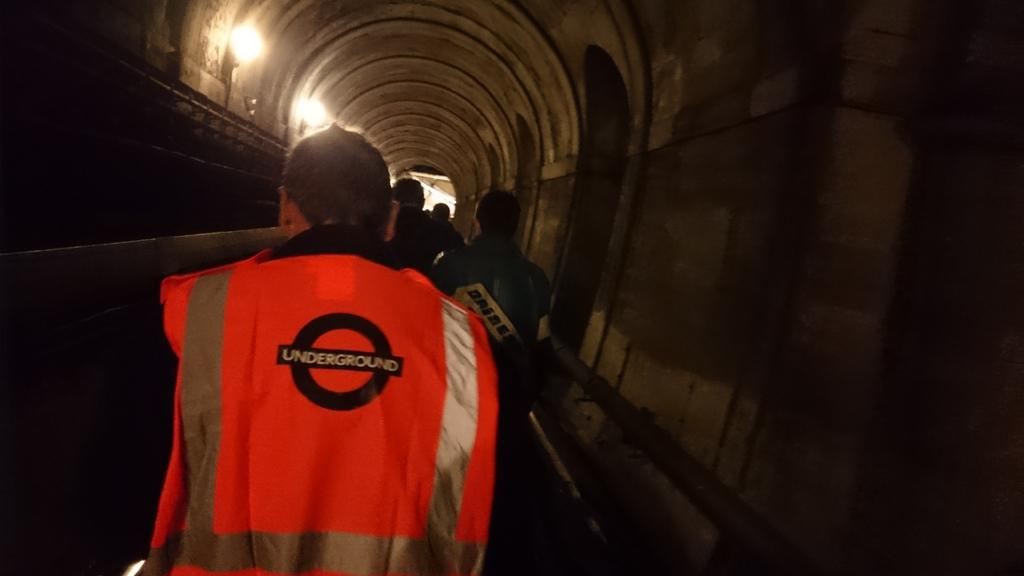<image>
Relay a brief, clear account of the picture shown. A maintenance worker wears a fluorescent orange vest with the London Underground logo on the back. 